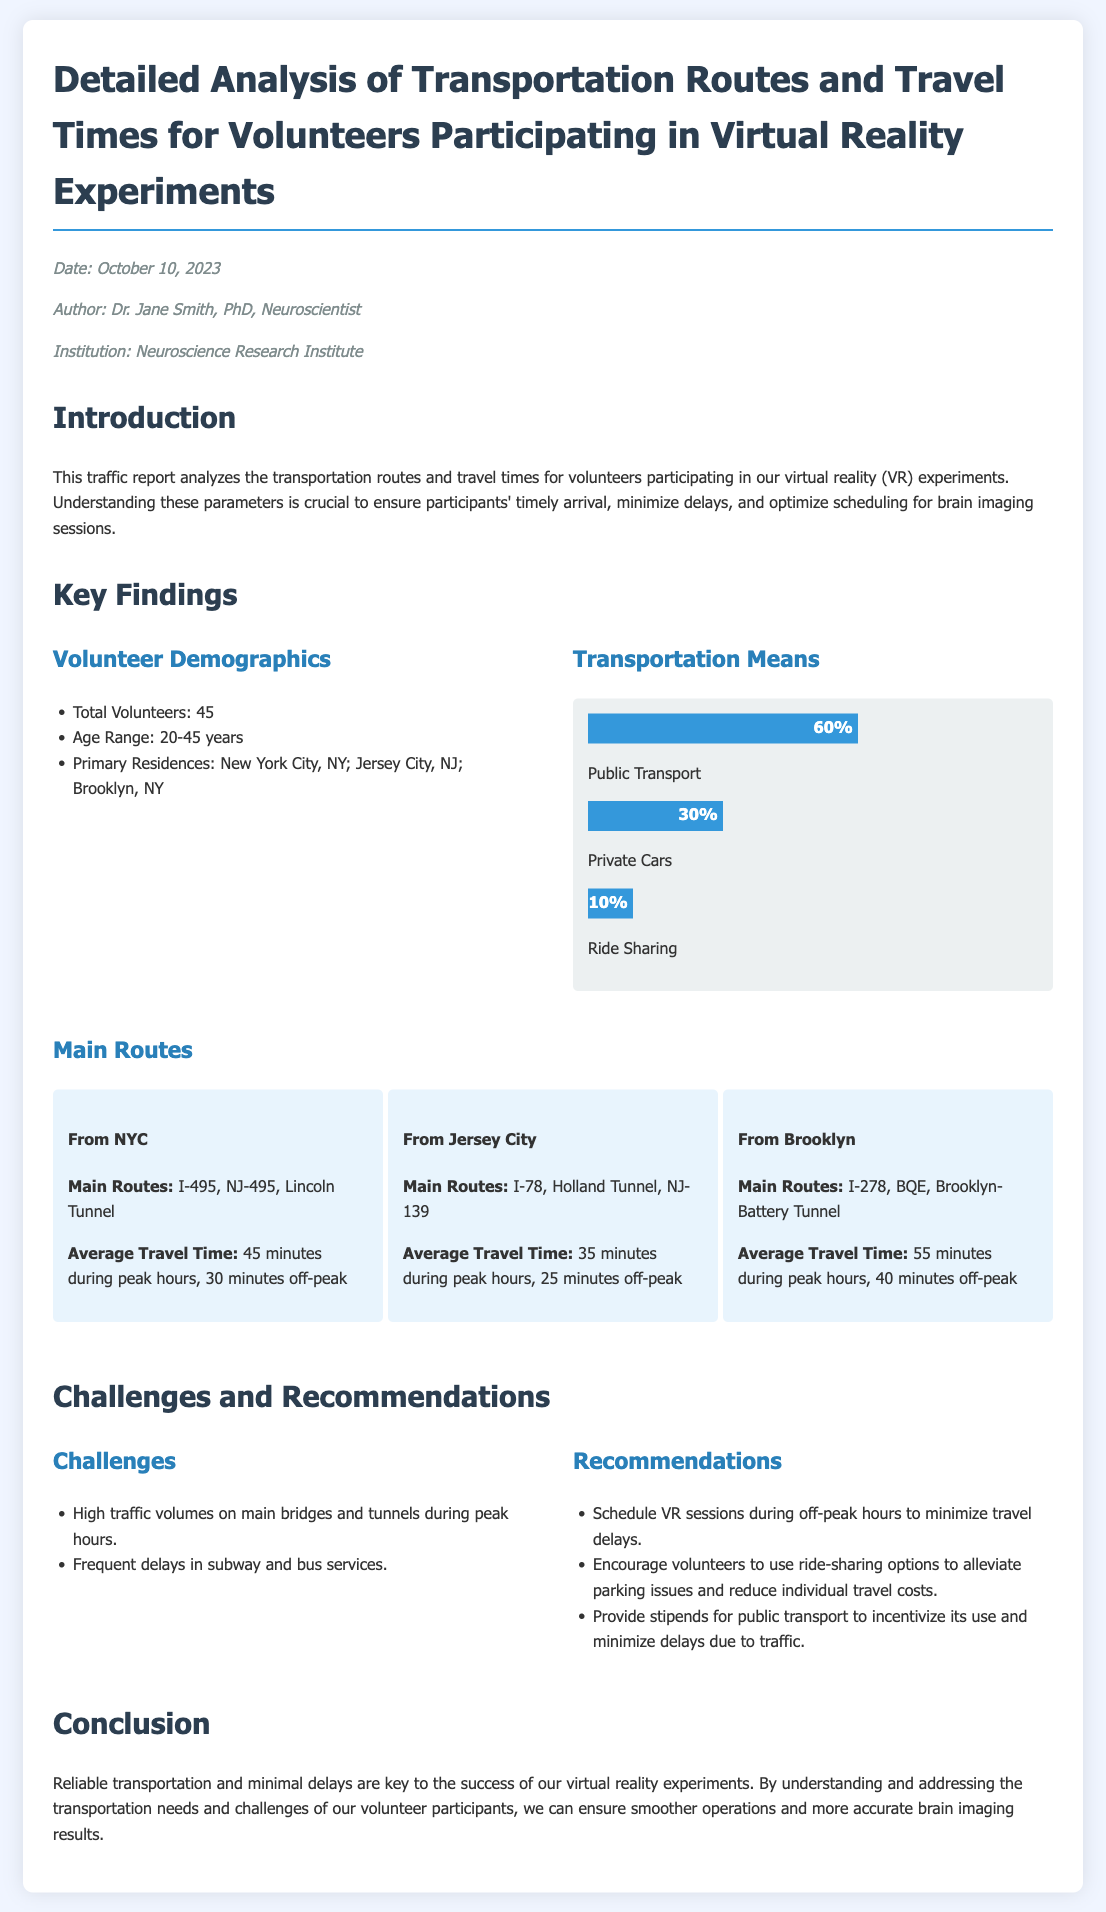What is the date of the report? The date of the report is mentioned in the author info section of the document.
Answer: October 10, 2023 How many total volunteers participated? The total number of volunteers is listed under the volunteer demographics section.
Answer: 45 What are the primary residences of the volunteers? The primary residences are detailed in the volunteer demographics section.
Answer: New York City, NY; Jersey City, NJ; Brooklyn, NY What is the average travel time from Jersey City during peak hours? The average travel time from Jersey City is reported in the main routes section of the document.
Answer: 35 minutes Which transportation means has the highest percentage usage? The transportation means with the highest percentage is indicated in the transportation means section.
Answer: Public Transport What challenge is associated with high traffic? The challenge regarding traffic is highlighted under the challenges section of the document.
Answer: High traffic volumes on main bridges and tunnels during peak hours What recommendation is made regarding session scheduling? A specific recommendation related to scheduling is provided in the recommendations section.
Answer: Schedule VR sessions during off-peak hours What is a suggested incentive for public transport use? An incentive related to public transport is mentioned in the recommendations section.
Answer: Provide stipends for public transport 